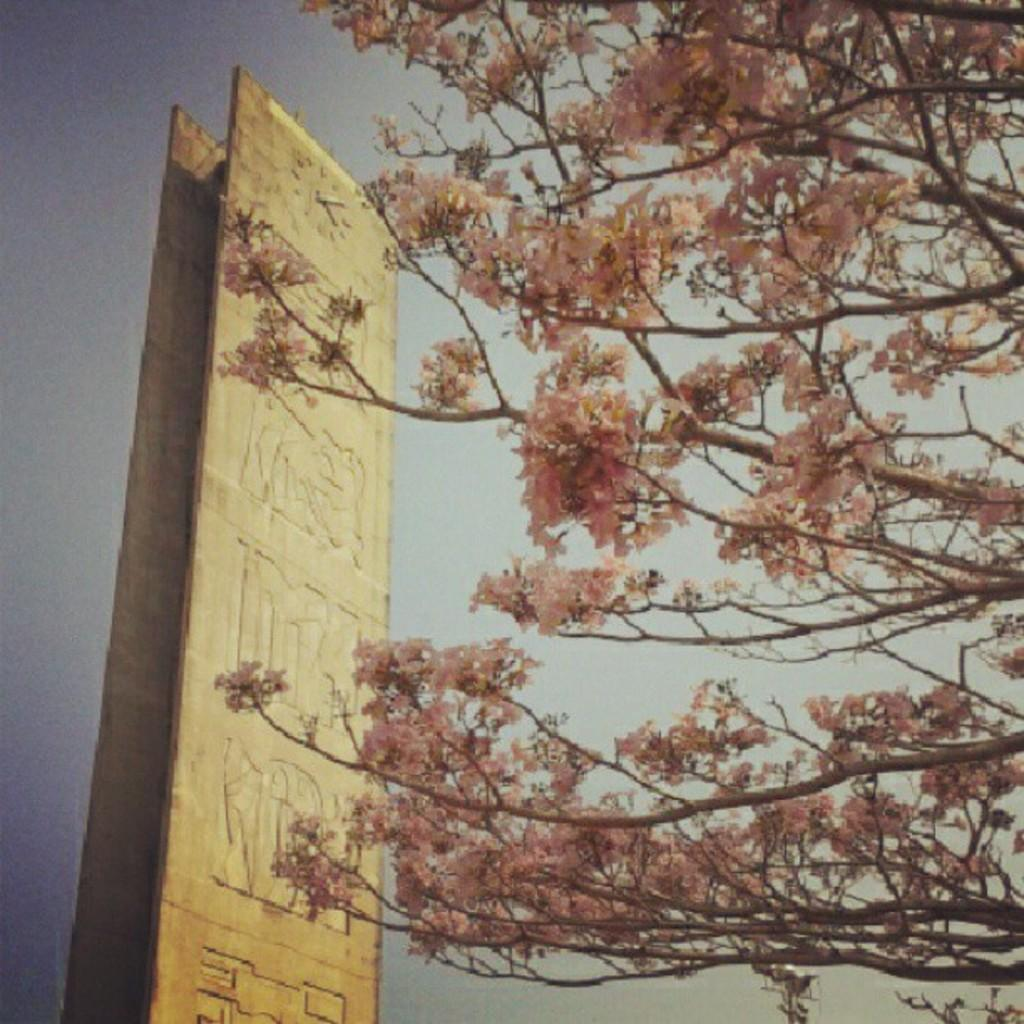What is the main object in the image? There is a wooden board in the image. What can be seen on the wooden board? The wooden board has carved structures on it. Is there any time-keeping device on the wooden board? Yes, there is a clock on the top of the wooden board. What type of vegetation is present on the right side of the image? There are branches with flowers on the right side of the image. What type of doll is sitting on the wooden board in the image? There is no doll present on the wooden board in the image. 